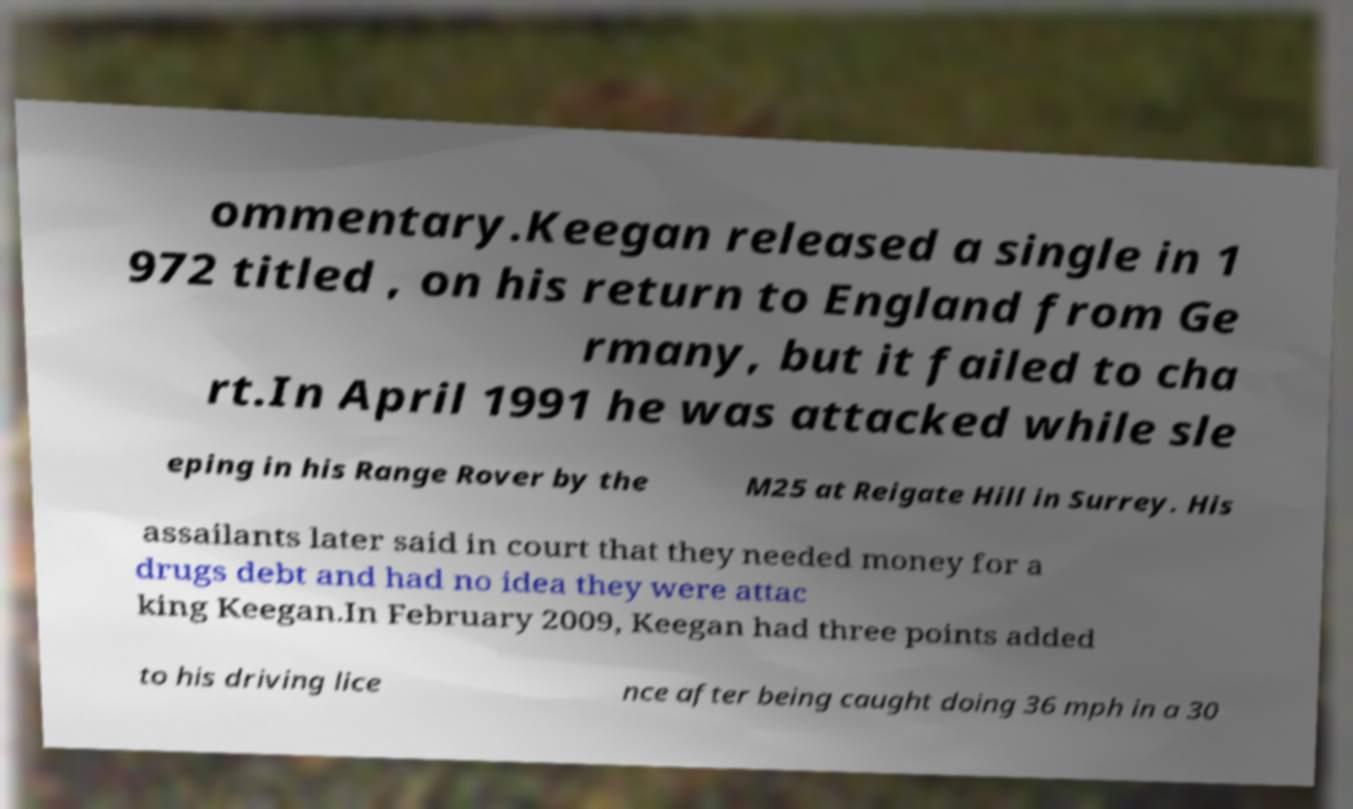Can you read and provide the text displayed in the image?This photo seems to have some interesting text. Can you extract and type it out for me? ommentary.Keegan released a single in 1 972 titled , on his return to England from Ge rmany, but it failed to cha rt.In April 1991 he was attacked while sle eping in his Range Rover by the M25 at Reigate Hill in Surrey. His assailants later said in court that they needed money for a drugs debt and had no idea they were attac king Keegan.In February 2009, Keegan had three points added to his driving lice nce after being caught doing 36 mph in a 30 